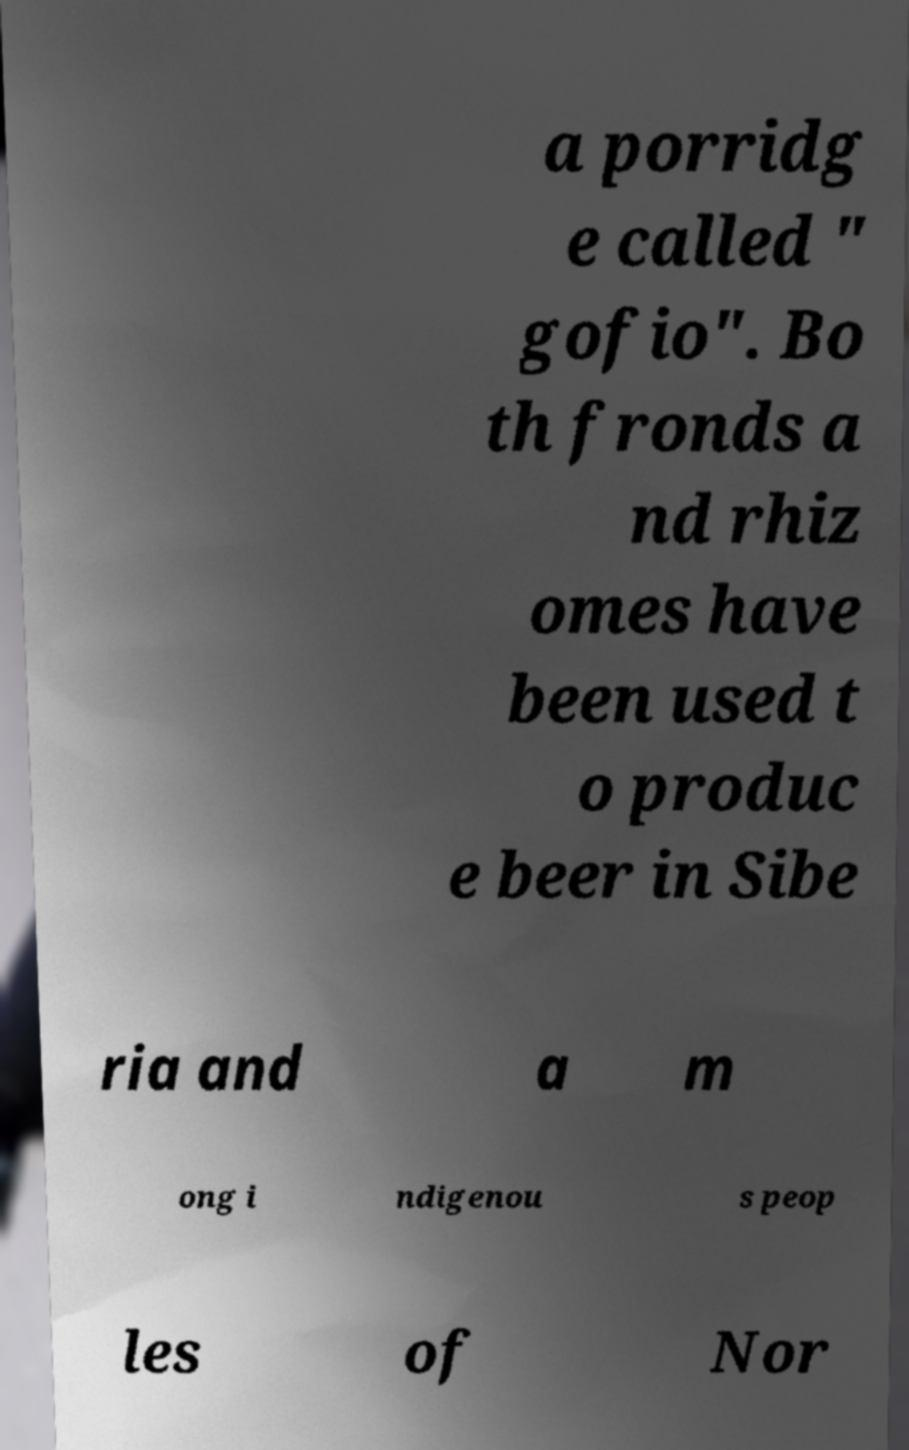Can you read and provide the text displayed in the image?This photo seems to have some interesting text. Can you extract and type it out for me? a porridg e called " gofio". Bo th fronds a nd rhiz omes have been used t o produc e beer in Sibe ria and a m ong i ndigenou s peop les of Nor 